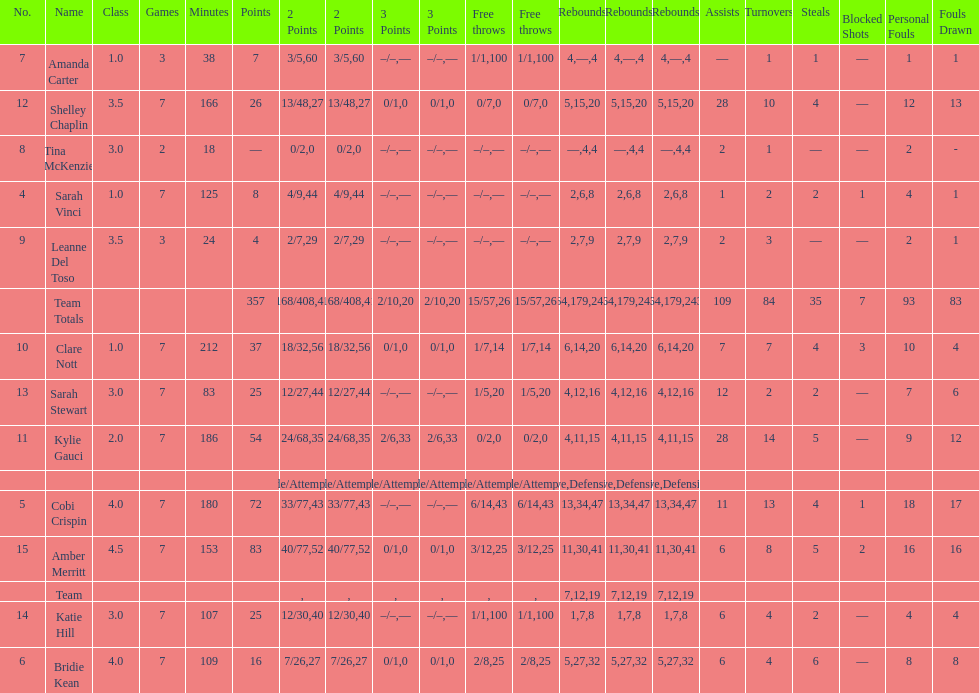Next to merritt, who was the top scorer? Cobi Crispin. 